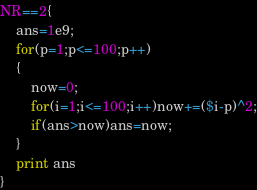Convert code to text. <code><loc_0><loc_0><loc_500><loc_500><_Awk_>NR==2{
	ans=1e9;
	for(p=1;p<=100;p++)
	{
		now=0;
		for(i=1;i<=100;i++)now+=($i-p)^2;
		if(ans>now)ans=now;
	}
	print ans
}
</code> 